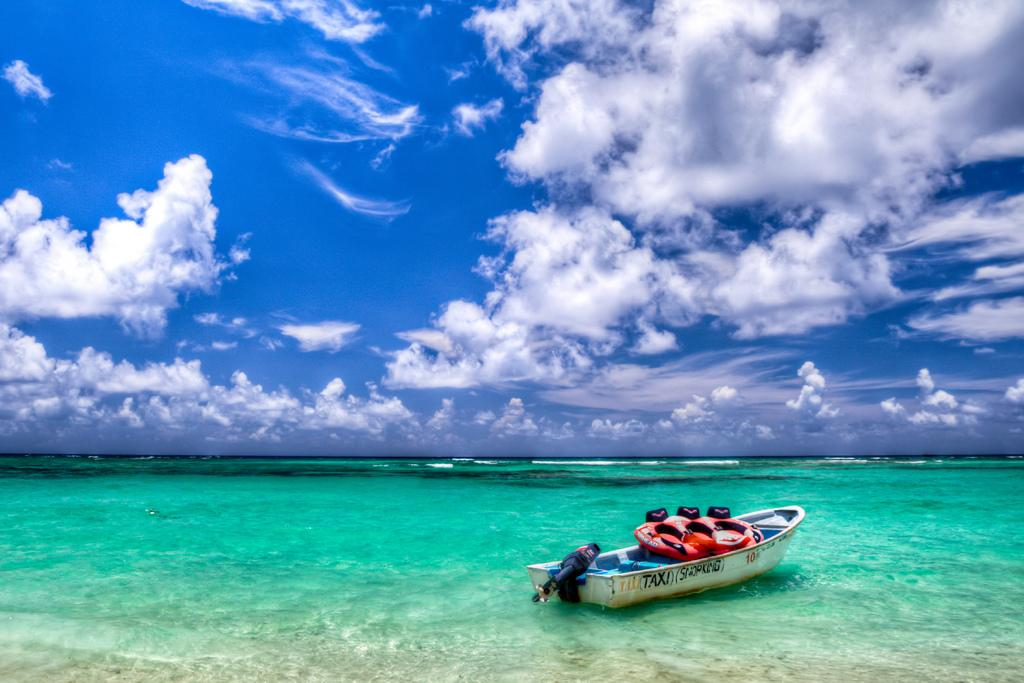<image>
Give a short and clear explanation of the subsequent image. A boat with the words (Taxi) (Snorking) on the side sits in beautiful aqua blue water. 